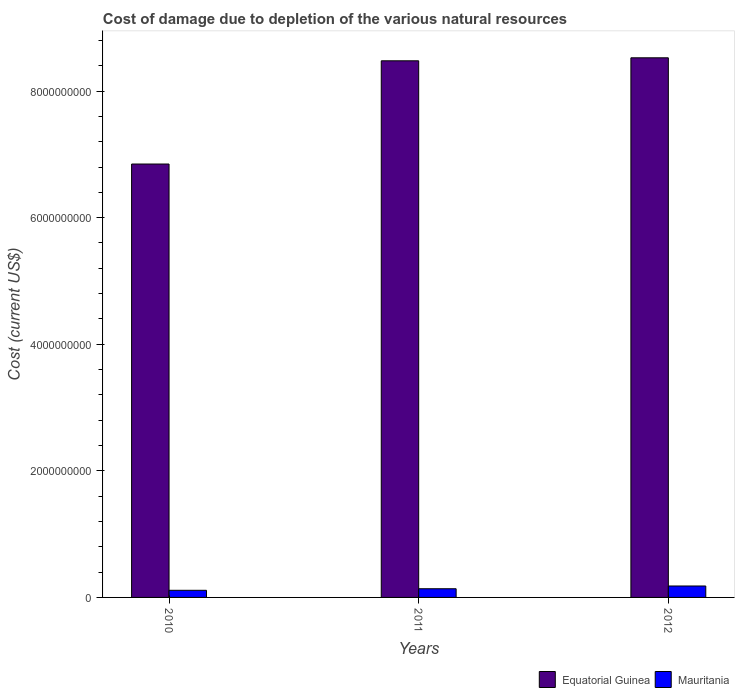How many different coloured bars are there?
Make the answer very short. 2. Are the number of bars per tick equal to the number of legend labels?
Your answer should be compact. Yes. Are the number of bars on each tick of the X-axis equal?
Offer a very short reply. Yes. How many bars are there on the 2nd tick from the right?
Keep it short and to the point. 2. What is the cost of damage caused due to the depletion of various natural resources in Mauritania in 2010?
Your answer should be compact. 1.13e+08. Across all years, what is the maximum cost of damage caused due to the depletion of various natural resources in Equatorial Guinea?
Make the answer very short. 8.53e+09. Across all years, what is the minimum cost of damage caused due to the depletion of various natural resources in Mauritania?
Offer a very short reply. 1.13e+08. What is the total cost of damage caused due to the depletion of various natural resources in Mauritania in the graph?
Provide a succinct answer. 4.30e+08. What is the difference between the cost of damage caused due to the depletion of various natural resources in Mauritania in 2010 and that in 2012?
Provide a short and direct response. -6.81e+07. What is the difference between the cost of damage caused due to the depletion of various natural resources in Mauritania in 2011 and the cost of damage caused due to the depletion of various natural resources in Equatorial Guinea in 2012?
Offer a terse response. -8.39e+09. What is the average cost of damage caused due to the depletion of various natural resources in Mauritania per year?
Offer a terse response. 1.43e+08. In the year 2010, what is the difference between the cost of damage caused due to the depletion of various natural resources in Mauritania and cost of damage caused due to the depletion of various natural resources in Equatorial Guinea?
Your response must be concise. -6.73e+09. In how many years, is the cost of damage caused due to the depletion of various natural resources in Mauritania greater than 7600000000 US$?
Ensure brevity in your answer.  0. What is the ratio of the cost of damage caused due to the depletion of various natural resources in Mauritania in 2010 to that in 2011?
Provide a short and direct response. 0.82. What is the difference between the highest and the second highest cost of damage caused due to the depletion of various natural resources in Equatorial Guinea?
Your answer should be very brief. 4.75e+07. What is the difference between the highest and the lowest cost of damage caused due to the depletion of various natural resources in Equatorial Guinea?
Your answer should be very brief. 1.68e+09. In how many years, is the cost of damage caused due to the depletion of various natural resources in Equatorial Guinea greater than the average cost of damage caused due to the depletion of various natural resources in Equatorial Guinea taken over all years?
Offer a terse response. 2. What does the 1st bar from the left in 2011 represents?
Offer a terse response. Equatorial Guinea. What does the 2nd bar from the right in 2012 represents?
Offer a terse response. Equatorial Guinea. How many bars are there?
Ensure brevity in your answer.  6. Are the values on the major ticks of Y-axis written in scientific E-notation?
Give a very brief answer. No. Does the graph contain any zero values?
Make the answer very short. No. Does the graph contain grids?
Offer a terse response. No. Where does the legend appear in the graph?
Offer a very short reply. Bottom right. How many legend labels are there?
Your answer should be very brief. 2. What is the title of the graph?
Give a very brief answer. Cost of damage due to depletion of the various natural resources. What is the label or title of the X-axis?
Provide a succinct answer. Years. What is the label or title of the Y-axis?
Provide a succinct answer. Cost (current US$). What is the Cost (current US$) in Equatorial Guinea in 2010?
Your answer should be compact. 6.85e+09. What is the Cost (current US$) in Mauritania in 2010?
Your response must be concise. 1.13e+08. What is the Cost (current US$) in Equatorial Guinea in 2011?
Give a very brief answer. 8.48e+09. What is the Cost (current US$) of Mauritania in 2011?
Your answer should be very brief. 1.37e+08. What is the Cost (current US$) in Equatorial Guinea in 2012?
Your answer should be very brief. 8.53e+09. What is the Cost (current US$) in Mauritania in 2012?
Give a very brief answer. 1.81e+08. Across all years, what is the maximum Cost (current US$) in Equatorial Guinea?
Offer a terse response. 8.53e+09. Across all years, what is the maximum Cost (current US$) of Mauritania?
Your response must be concise. 1.81e+08. Across all years, what is the minimum Cost (current US$) of Equatorial Guinea?
Make the answer very short. 6.85e+09. Across all years, what is the minimum Cost (current US$) of Mauritania?
Your response must be concise. 1.13e+08. What is the total Cost (current US$) of Equatorial Guinea in the graph?
Keep it short and to the point. 2.39e+1. What is the total Cost (current US$) of Mauritania in the graph?
Ensure brevity in your answer.  4.30e+08. What is the difference between the Cost (current US$) in Equatorial Guinea in 2010 and that in 2011?
Your response must be concise. -1.63e+09. What is the difference between the Cost (current US$) of Mauritania in 2010 and that in 2011?
Keep it short and to the point. -2.45e+07. What is the difference between the Cost (current US$) in Equatorial Guinea in 2010 and that in 2012?
Give a very brief answer. -1.68e+09. What is the difference between the Cost (current US$) of Mauritania in 2010 and that in 2012?
Ensure brevity in your answer.  -6.81e+07. What is the difference between the Cost (current US$) in Equatorial Guinea in 2011 and that in 2012?
Provide a short and direct response. -4.75e+07. What is the difference between the Cost (current US$) of Mauritania in 2011 and that in 2012?
Ensure brevity in your answer.  -4.36e+07. What is the difference between the Cost (current US$) in Equatorial Guinea in 2010 and the Cost (current US$) in Mauritania in 2011?
Your response must be concise. 6.71e+09. What is the difference between the Cost (current US$) in Equatorial Guinea in 2010 and the Cost (current US$) in Mauritania in 2012?
Make the answer very short. 6.67e+09. What is the difference between the Cost (current US$) of Equatorial Guinea in 2011 and the Cost (current US$) of Mauritania in 2012?
Offer a terse response. 8.30e+09. What is the average Cost (current US$) of Equatorial Guinea per year?
Keep it short and to the point. 7.95e+09. What is the average Cost (current US$) of Mauritania per year?
Your answer should be compact. 1.43e+08. In the year 2010, what is the difference between the Cost (current US$) in Equatorial Guinea and Cost (current US$) in Mauritania?
Give a very brief answer. 6.73e+09. In the year 2011, what is the difference between the Cost (current US$) of Equatorial Guinea and Cost (current US$) of Mauritania?
Offer a very short reply. 8.34e+09. In the year 2012, what is the difference between the Cost (current US$) of Equatorial Guinea and Cost (current US$) of Mauritania?
Keep it short and to the point. 8.34e+09. What is the ratio of the Cost (current US$) of Equatorial Guinea in 2010 to that in 2011?
Offer a terse response. 0.81. What is the ratio of the Cost (current US$) of Mauritania in 2010 to that in 2011?
Keep it short and to the point. 0.82. What is the ratio of the Cost (current US$) of Equatorial Guinea in 2010 to that in 2012?
Provide a succinct answer. 0.8. What is the ratio of the Cost (current US$) in Mauritania in 2010 to that in 2012?
Keep it short and to the point. 0.62. What is the ratio of the Cost (current US$) of Mauritania in 2011 to that in 2012?
Your answer should be compact. 0.76. What is the difference between the highest and the second highest Cost (current US$) of Equatorial Guinea?
Your answer should be very brief. 4.75e+07. What is the difference between the highest and the second highest Cost (current US$) in Mauritania?
Your answer should be very brief. 4.36e+07. What is the difference between the highest and the lowest Cost (current US$) in Equatorial Guinea?
Keep it short and to the point. 1.68e+09. What is the difference between the highest and the lowest Cost (current US$) in Mauritania?
Provide a short and direct response. 6.81e+07. 